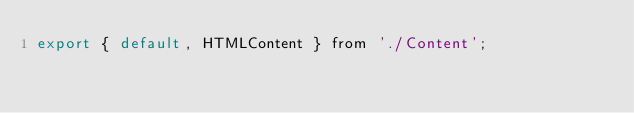<code> <loc_0><loc_0><loc_500><loc_500><_JavaScript_>export { default, HTMLContent } from './Content';
</code> 